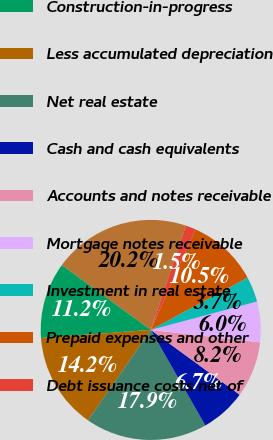Convert chart. <chart><loc_0><loc_0><loc_500><loc_500><pie_chart><fcel>Operating<fcel>Construction-in-progress<fcel>Less accumulated depreciation<fcel>Net real estate<fcel>Cash and cash equivalents<fcel>Accounts and notes receivable<fcel>Mortgage notes receivable<fcel>Investment in real estate<fcel>Prepaid expenses and other<fcel>Debt issuance costs net of<nl><fcel>20.15%<fcel>11.19%<fcel>14.18%<fcel>17.91%<fcel>6.72%<fcel>8.21%<fcel>5.97%<fcel>3.73%<fcel>10.45%<fcel>1.49%<nl></chart> 